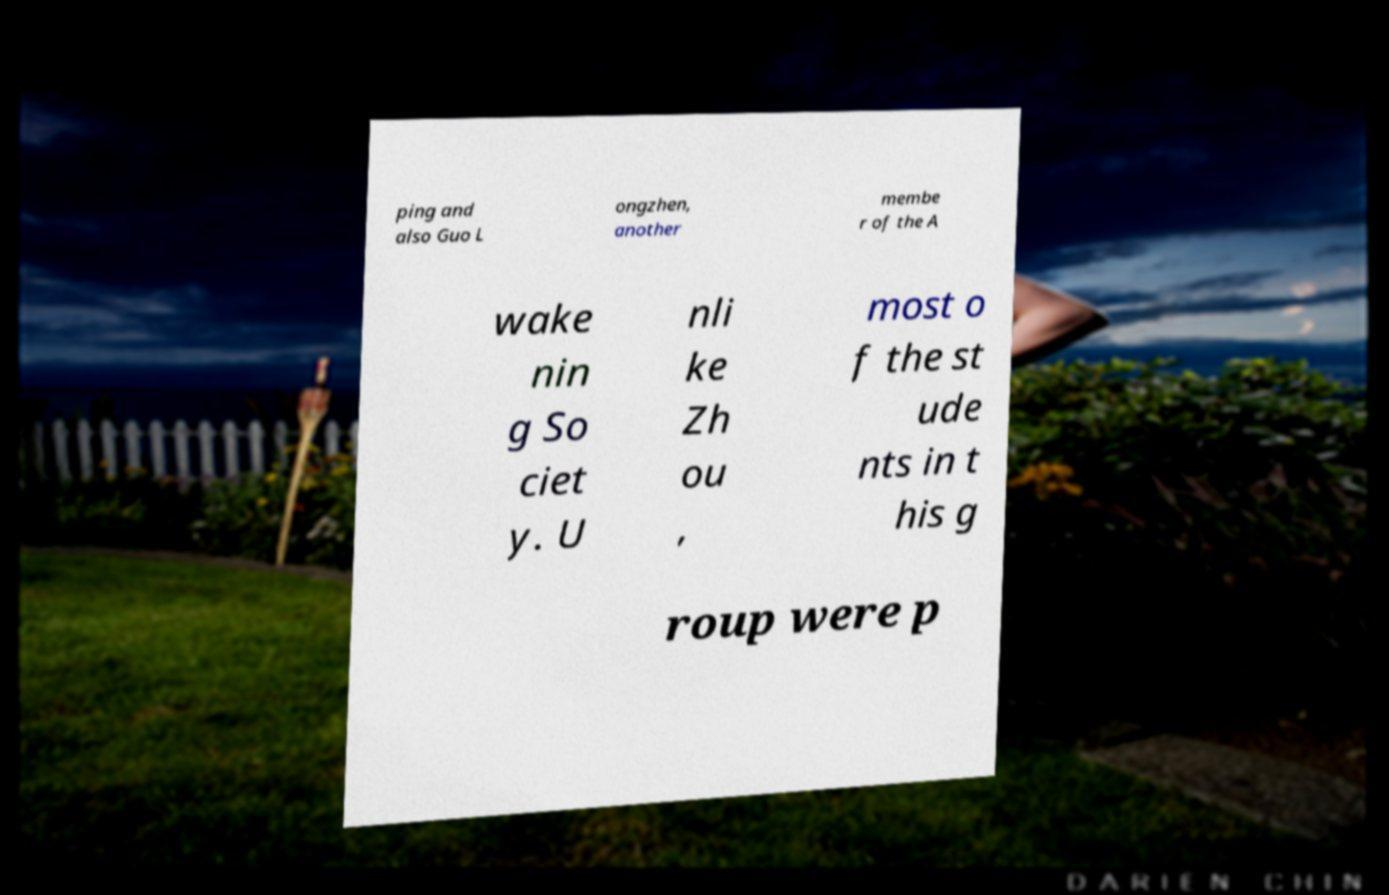There's text embedded in this image that I need extracted. Can you transcribe it verbatim? ping and also Guo L ongzhen, another membe r of the A wake nin g So ciet y. U nli ke Zh ou , most o f the st ude nts in t his g roup were p 